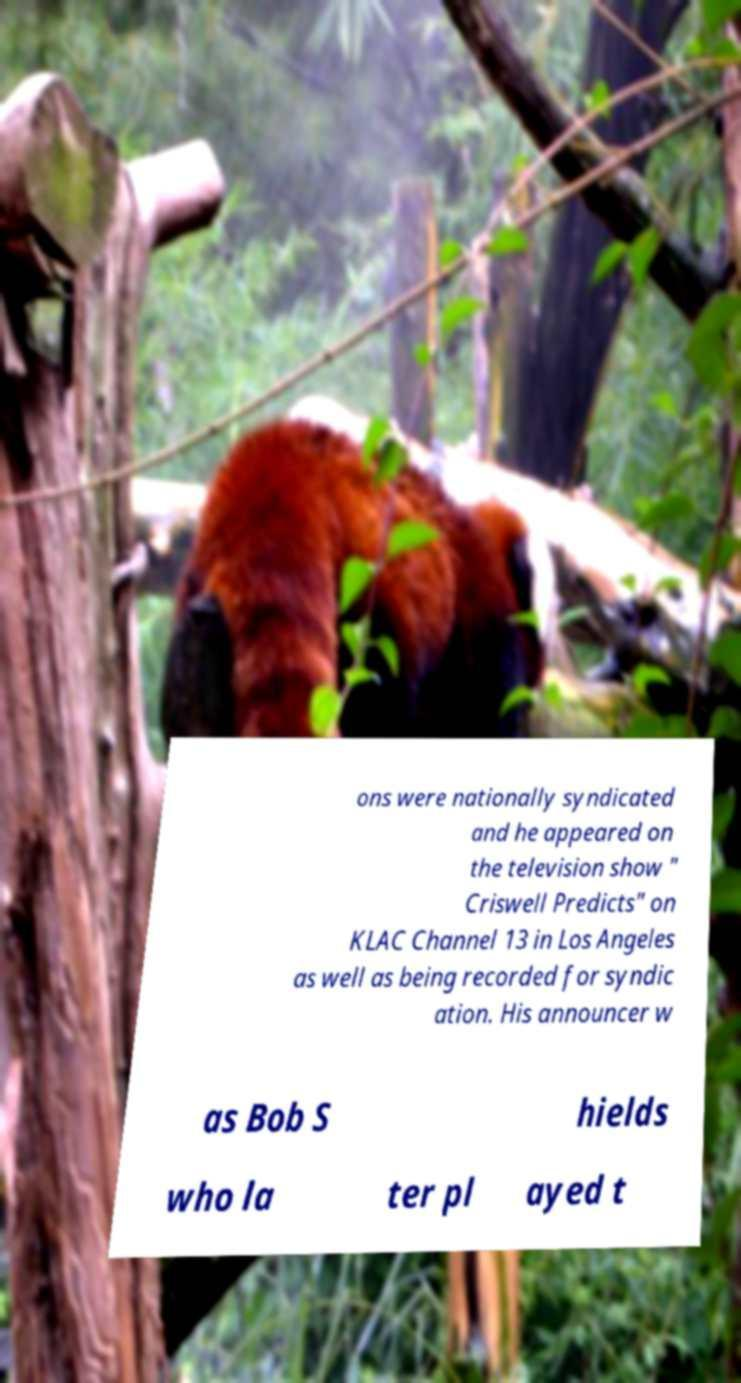For documentation purposes, I need the text within this image transcribed. Could you provide that? ons were nationally syndicated and he appeared on the television show " Criswell Predicts" on KLAC Channel 13 in Los Angeles as well as being recorded for syndic ation. His announcer w as Bob S hields who la ter pl ayed t 